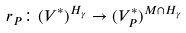Convert formula to latex. <formula><loc_0><loc_0><loc_500><loc_500>r _ { P } \colon ( V ^ { * } ) ^ { H _ { \gamma } } \to ( V _ { P } ^ { * } ) ^ { M \cap H _ { \gamma } }</formula> 